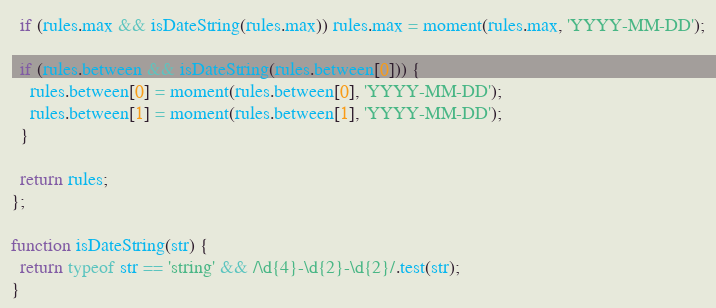<code> <loc_0><loc_0><loc_500><loc_500><_JavaScript_>
  if (rules.max && isDateString(rules.max)) rules.max = moment(rules.max, 'YYYY-MM-DD');

  if (rules.between && isDateString(rules.between[0])) {
    rules.between[0] = moment(rules.between[0], 'YYYY-MM-DD');
    rules.between[1] = moment(rules.between[1], 'YYYY-MM-DD');
  }

  return rules;
};

function isDateString(str) {
  return typeof str == 'string' && /\d{4}-\d{2}-\d{2}/.test(str);
}</code> 